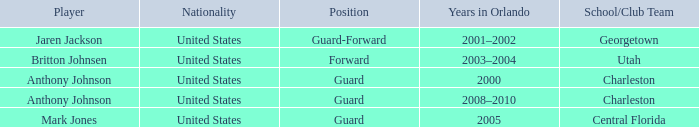Who occupied the guard-forward position as a player? Jaren Jackson. 